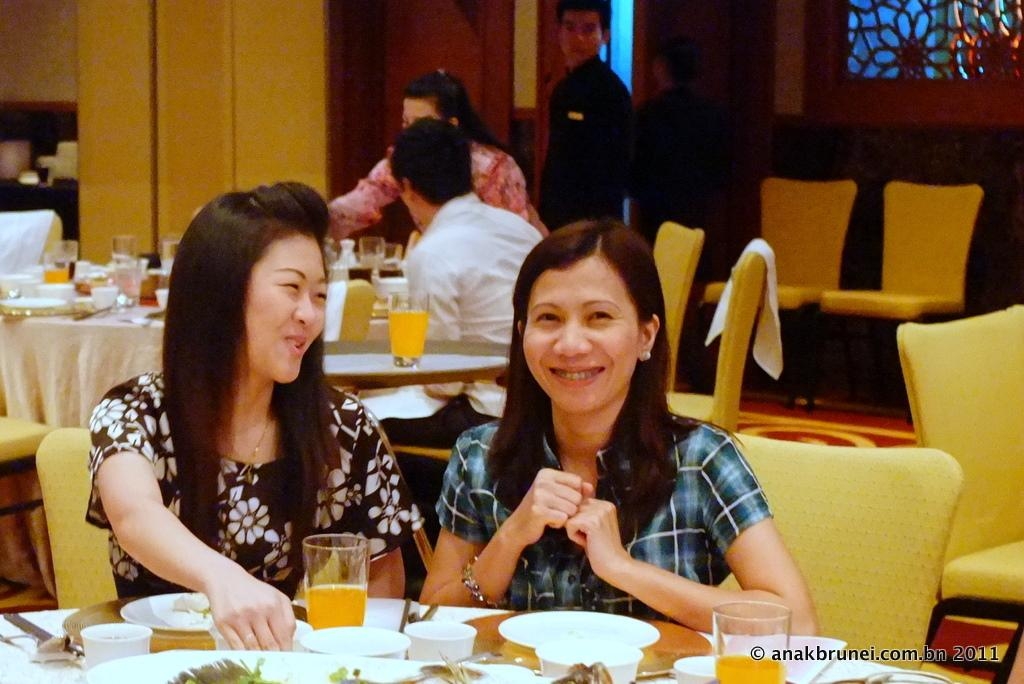What are the people in the image doing? There are people sitting on chairs in the image. What objects can be seen on the table in the image? There are plates and glasses on the table in the image. Can you describe the expressions of the people in the image? Some people in the image are smiling. What grade does the person with the best hair receive in the image? There is no mention of grades or hair in the image, so this question cannot be answered. 